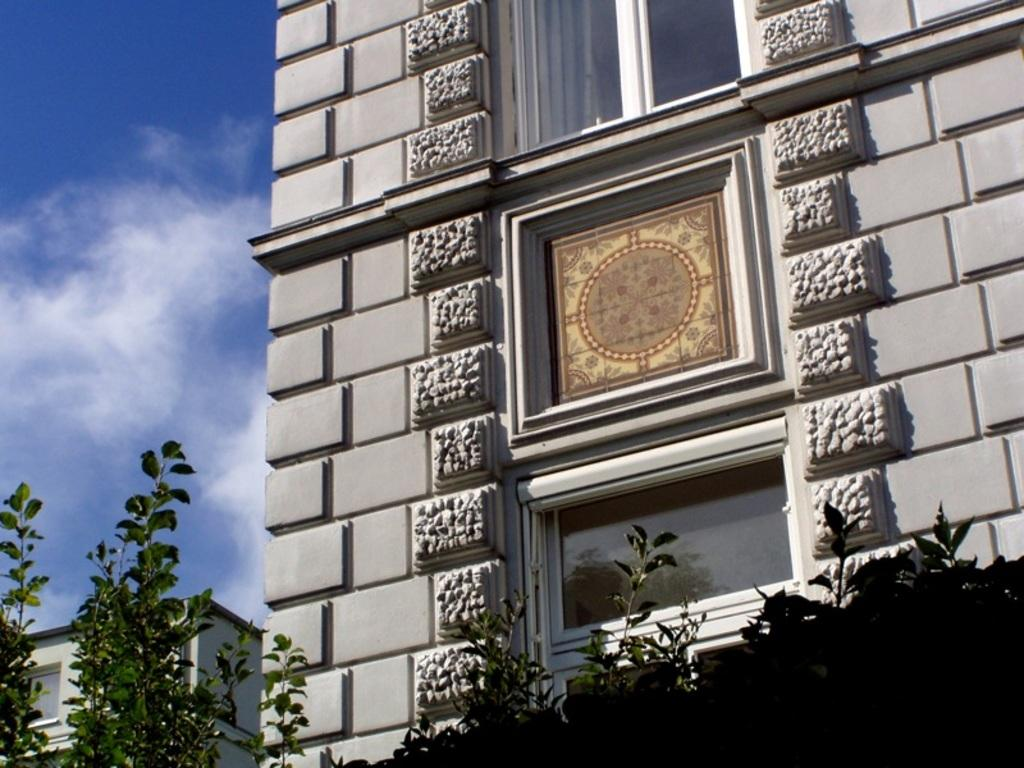What type of living organisms can be seen in the image? Plants can be seen in the image. What type of structures are visible in the background of the image? There are buildings in the background of the image. What part of the natural environment is visible in the image? The sky is visible in the background of the image. What type of silver toothbrush does the grandfather use in the image? There is no grandfather or toothbrush present in the image. 